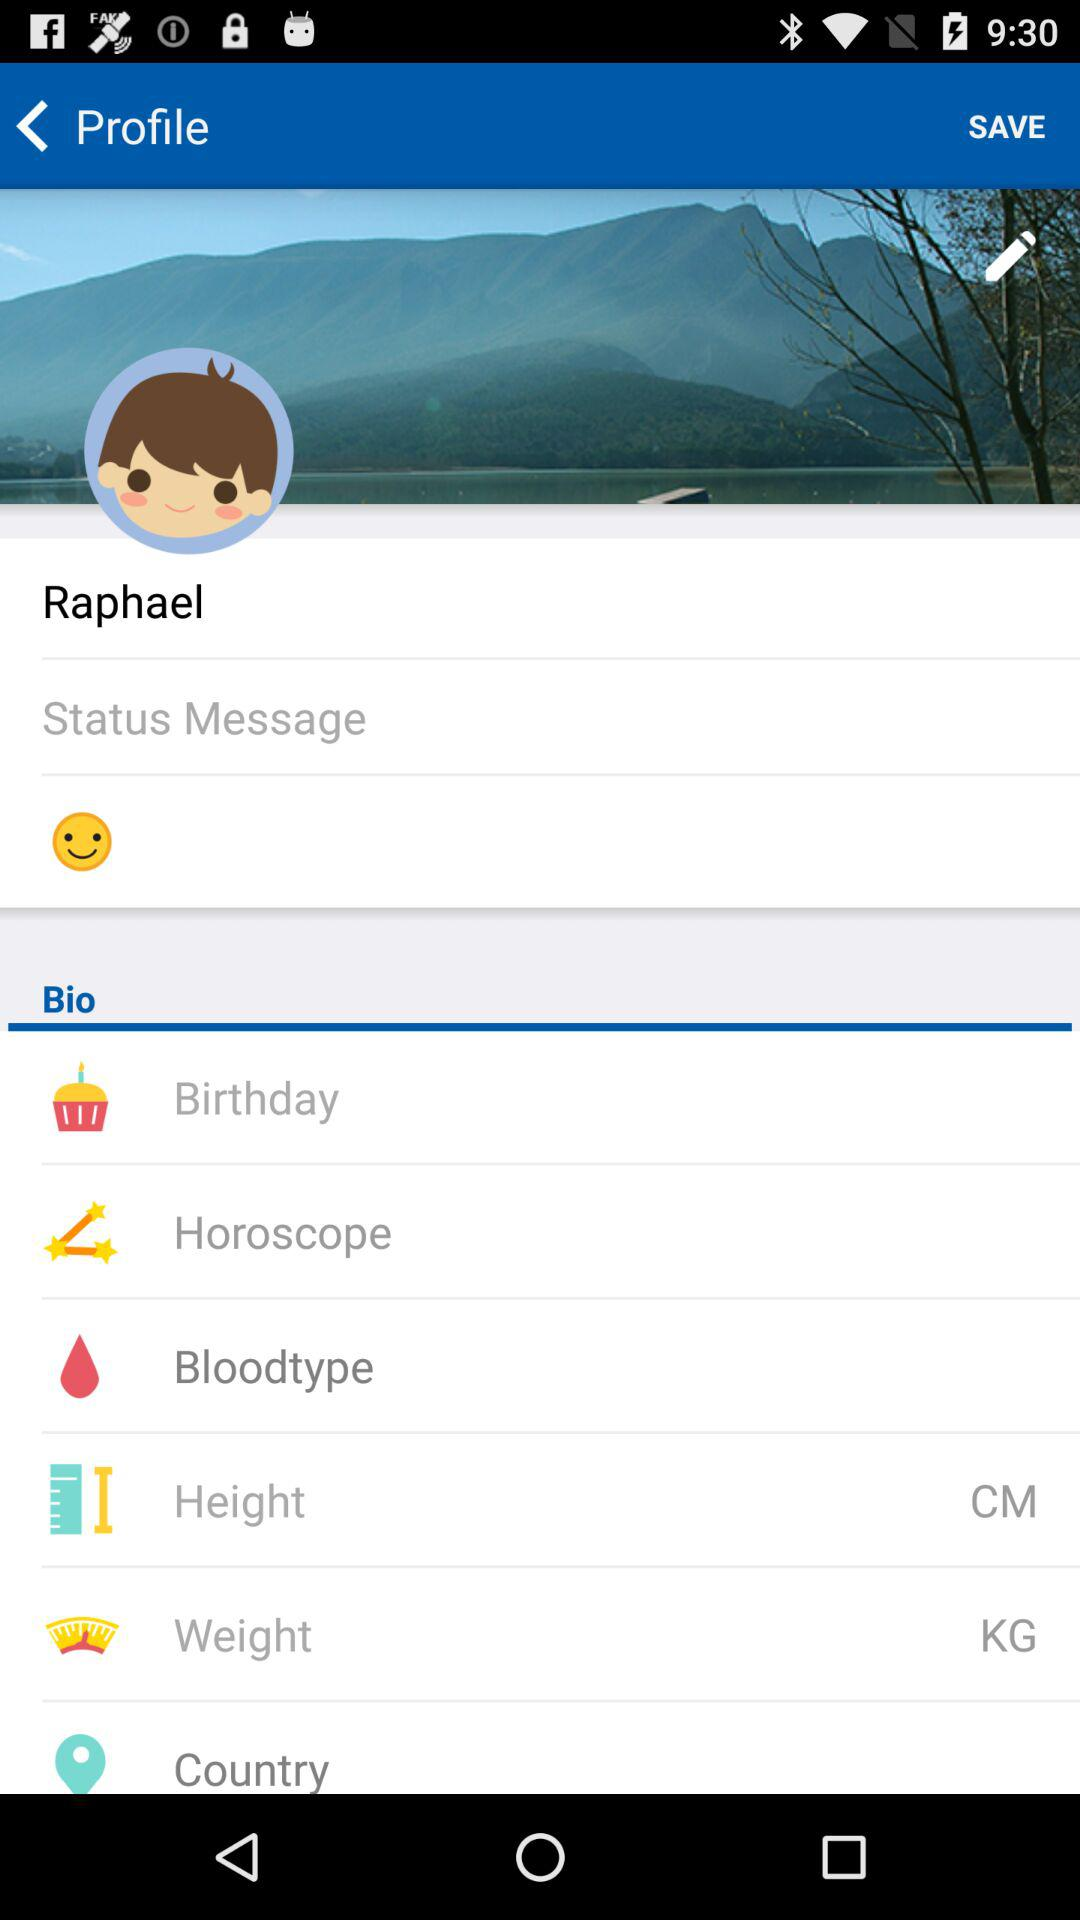What is the unit of weight? The unit of weight is KG. 